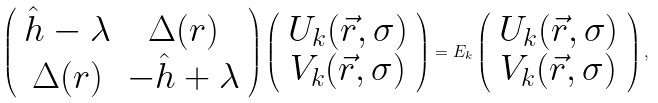Convert formula to latex. <formula><loc_0><loc_0><loc_500><loc_500>\left ( \begin{array} { c c } \hat { h } - \lambda & \Delta ( r ) \\ \Delta ( r ) & - \hat { h } + \lambda \end{array} \right ) \left ( \begin{array} { c } U _ { k } ( \vec { r } , \sigma ) \\ V _ { k } ( \vec { r } , \sigma ) \end{array} \right ) = E _ { k } \left ( \begin{array} { c } U _ { k } ( \vec { r } , \sigma ) \\ V _ { k } ( \vec { r } , \sigma ) \end{array} \right ) ,</formula> 